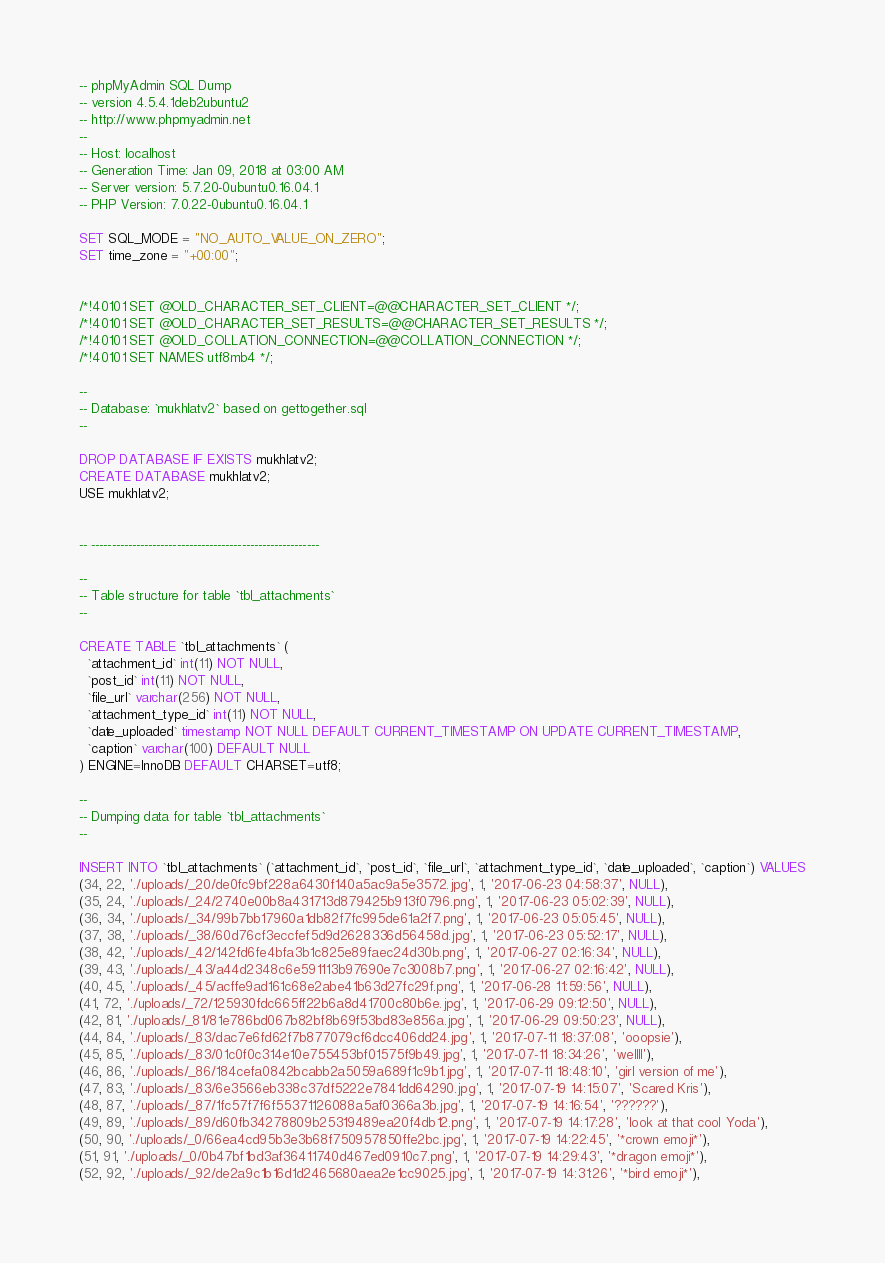Convert code to text. <code><loc_0><loc_0><loc_500><loc_500><_SQL_>-- phpMyAdmin SQL Dump
-- version 4.5.4.1deb2ubuntu2
-- http://www.phpmyadmin.net
--
-- Host: localhost
-- Generation Time: Jan 09, 2018 at 03:00 AM
-- Server version: 5.7.20-0ubuntu0.16.04.1
-- PHP Version: 7.0.22-0ubuntu0.16.04.1

SET SQL_MODE = "NO_AUTO_VALUE_ON_ZERO";
SET time_zone = "+00:00";


/*!40101 SET @OLD_CHARACTER_SET_CLIENT=@@CHARACTER_SET_CLIENT */;
/*!40101 SET @OLD_CHARACTER_SET_RESULTS=@@CHARACTER_SET_RESULTS */;
/*!40101 SET @OLD_COLLATION_CONNECTION=@@COLLATION_CONNECTION */;
/*!40101 SET NAMES utf8mb4 */;

--
-- Database: `mukhlatv2` based on gettogether.sql
--

DROP DATABASE IF EXISTS mukhlatv2;
CREATE DATABASE mukhlatv2;
USE mukhlatv2;


-- --------------------------------------------------------

--
-- Table structure for table `tbl_attachments`
--

CREATE TABLE `tbl_attachments` (
  `attachment_id` int(11) NOT NULL,
  `post_id` int(11) NOT NULL,
  `file_url` varchar(256) NOT NULL,
  `attachment_type_id` int(11) NOT NULL,
  `date_uploaded` timestamp NOT NULL DEFAULT CURRENT_TIMESTAMP ON UPDATE CURRENT_TIMESTAMP,
  `caption` varchar(100) DEFAULT NULL
) ENGINE=InnoDB DEFAULT CHARSET=utf8;

--
-- Dumping data for table `tbl_attachments`
--

INSERT INTO `tbl_attachments` (`attachment_id`, `post_id`, `file_url`, `attachment_type_id`, `date_uploaded`, `caption`) VALUES
(34, 22, './uploads/_20/de0fc9bf228a6430f140a5ac9a5e3572.jpg', 1, '2017-06-23 04:58:37', NULL),
(35, 24, './uploads/_24/2740e00b8a431713d879425b913f0796.png', 1, '2017-06-23 05:02:39', NULL),
(36, 34, './uploads/_34/99b7bb17960a1db82f7fc995de61a2f7.png', 1, '2017-06-23 05:05:45', NULL),
(37, 38, './uploads/_38/60d76cf3eccfef5d9d2628336d56458d.jpg', 1, '2017-06-23 05:52:17', NULL),
(38, 42, './uploads/_42/142fd6fe4bfa3b1c825e89faec24d30b.png', 1, '2017-06-27 02:16:34', NULL),
(39, 43, './uploads/_43/a44d2348c6e591113b97690e7c3008b7.png', 1, '2017-06-27 02:16:42', NULL),
(40, 45, './uploads/_45/acffe9ad161c68e2abe41b63d27fc29f.png', 1, '2017-06-28 11:59:56', NULL),
(41, 72, './uploads/_72/125930fdc665ff22b6a8d41700c80b6e.jpg', 1, '2017-06-29 09:12:50', NULL),
(42, 81, './uploads/_81/81e786bd067b82bf8b69f53bd83e856a.jpg', 1, '2017-06-29 09:50:23', NULL),
(44, 84, './uploads/_83/dac7e6fd62f7b877079cf6dcc406dd24.jpg', 1, '2017-07-11 18:37:08', 'ooopsie'),
(45, 85, './uploads/_83/01c0f0c314e10e755453bf01575f9b49.jpg', 1, '2017-07-11 18:34:26', 'wellll'),
(46, 86, './uploads/_86/184cefa0842bcabb2a5059a689f1c9b1.jpg', 1, '2017-07-11 18:48:10', 'girl version of me'),
(47, 83, './uploads/_83/6e3566eb338c37df5222e7841dd64290.jpg', 1, '2017-07-19 14:15:07', 'Scared Kris'),
(48, 87, './uploads/_87/1fc57f7f6f55371126088a5af0366a3b.jpg', 1, '2017-07-19 14:16:54', '??????'),
(49, 89, './uploads/_89/d60fb34278809b25319489ea20f4db12.png', 1, '2017-07-19 14:17:28', 'look at that cool Yoda'),
(50, 90, './uploads/_0/66ea4cd95b3e3b68f750957850ffe2bc.jpg', 1, '2017-07-19 14:22:45', '*crown emoji*'),
(51, 91, './uploads/_0/0b47bf1bd3af36411740d467ed0910c7.png', 1, '2017-07-19 14:29:43', '*dragon emoji*'),
(52, 92, './uploads/_92/de2a9c1b16d1d2465680aea2e1cc9025.jpg', 1, '2017-07-19 14:31:26', '*bird emoji*'),</code> 